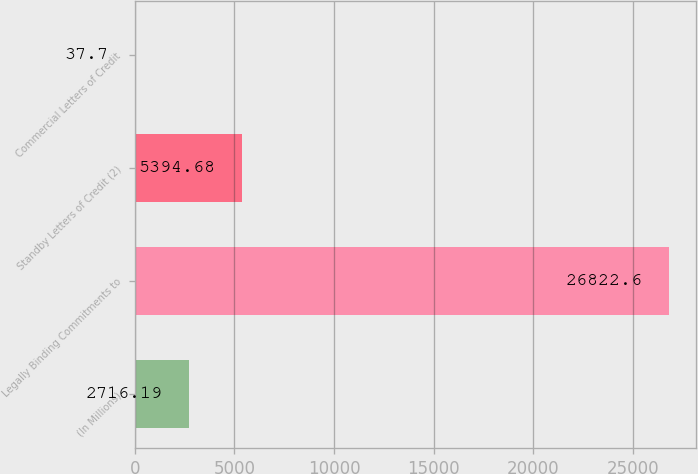Convert chart to OTSL. <chart><loc_0><loc_0><loc_500><loc_500><bar_chart><fcel>(In Millions)<fcel>Legally Binding Commitments to<fcel>Standby Letters of Credit (2)<fcel>Commercial Letters of Credit<nl><fcel>2716.19<fcel>26822.6<fcel>5394.68<fcel>37.7<nl></chart> 